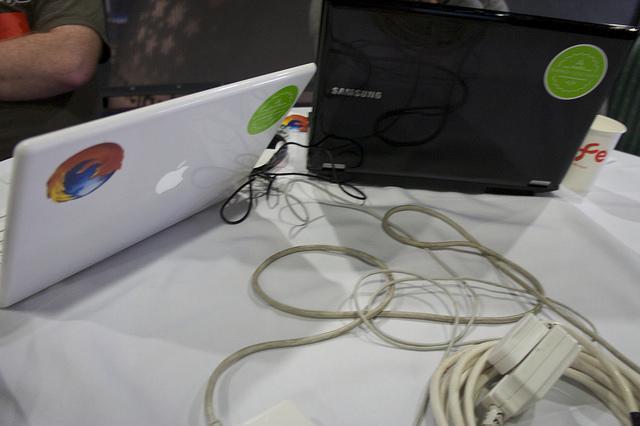How many computers are there?
Give a very brief answer. 2. How many laptops are in the picture?
Give a very brief answer. 2. 